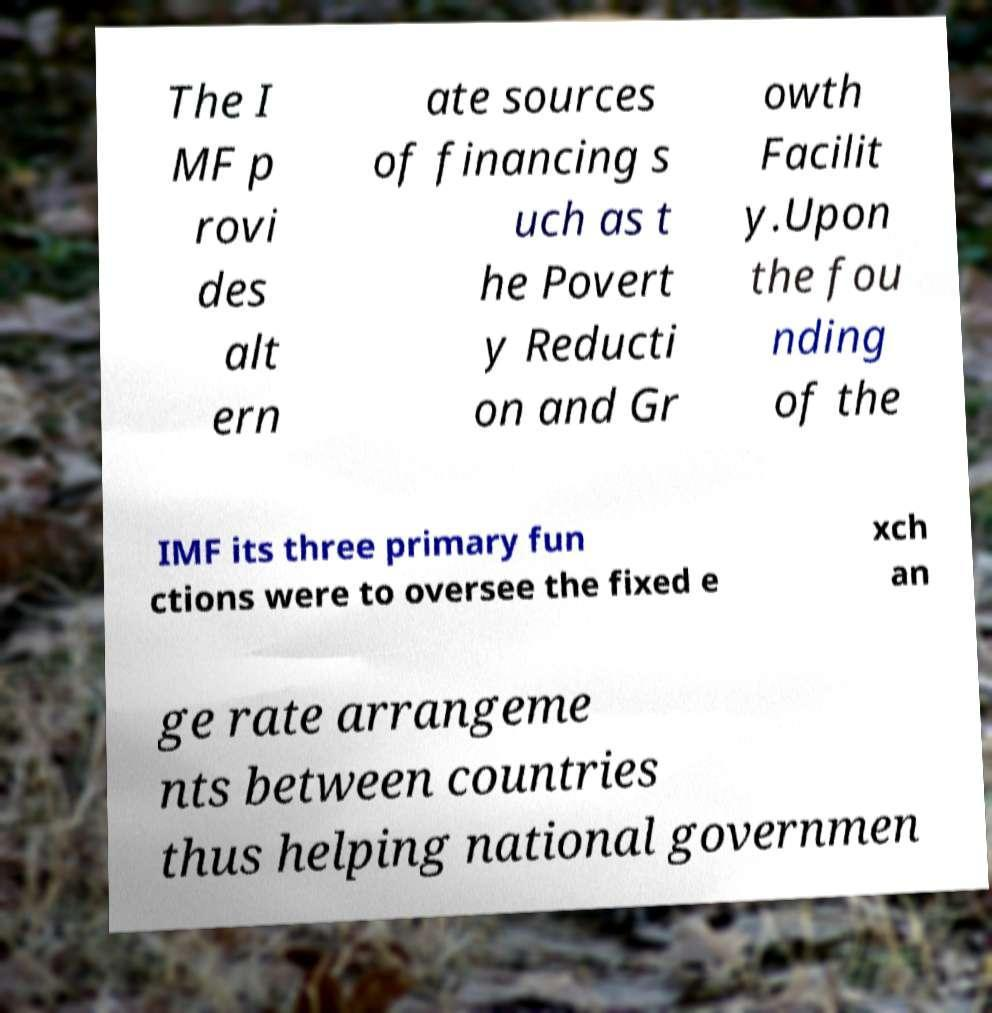Can you accurately transcribe the text from the provided image for me? The I MF p rovi des alt ern ate sources of financing s uch as t he Povert y Reducti on and Gr owth Facilit y.Upon the fou nding of the IMF its three primary fun ctions were to oversee the fixed e xch an ge rate arrangeme nts between countries thus helping national governmen 